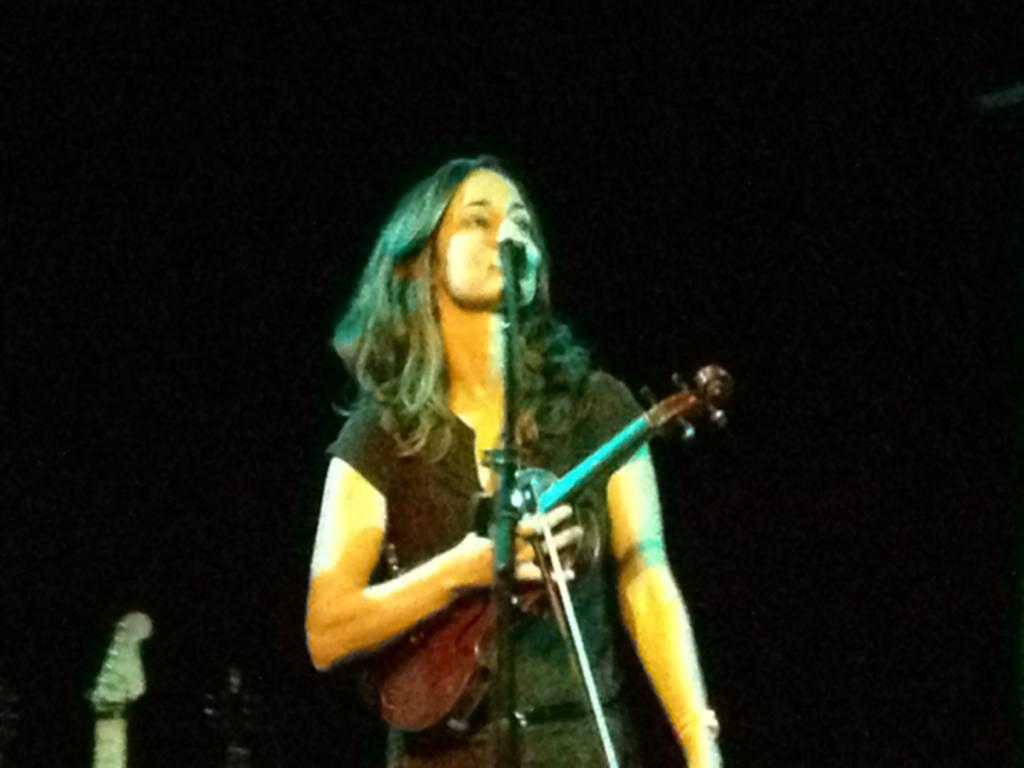What is the main subject of the image? There is a woman in the image. What is the woman holding in the image? The woman is holding a violin. What is the woman doing in the image? The woman is singing. What object is present that might be used for amplifying her voice? There is a microphone in the image. Can you see any squirrels washing spoons in the image? There are no squirrels or spoons present in the image. 